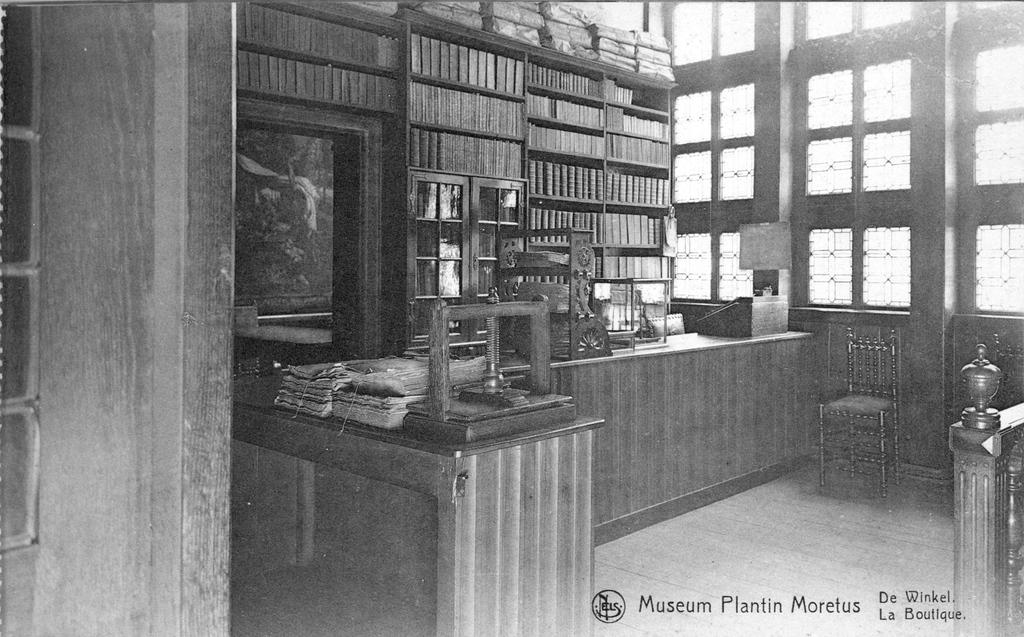<image>
Provide a brief description of the given image. An old photograph from the Museum Plantin Moretus shows shelves full of books. 